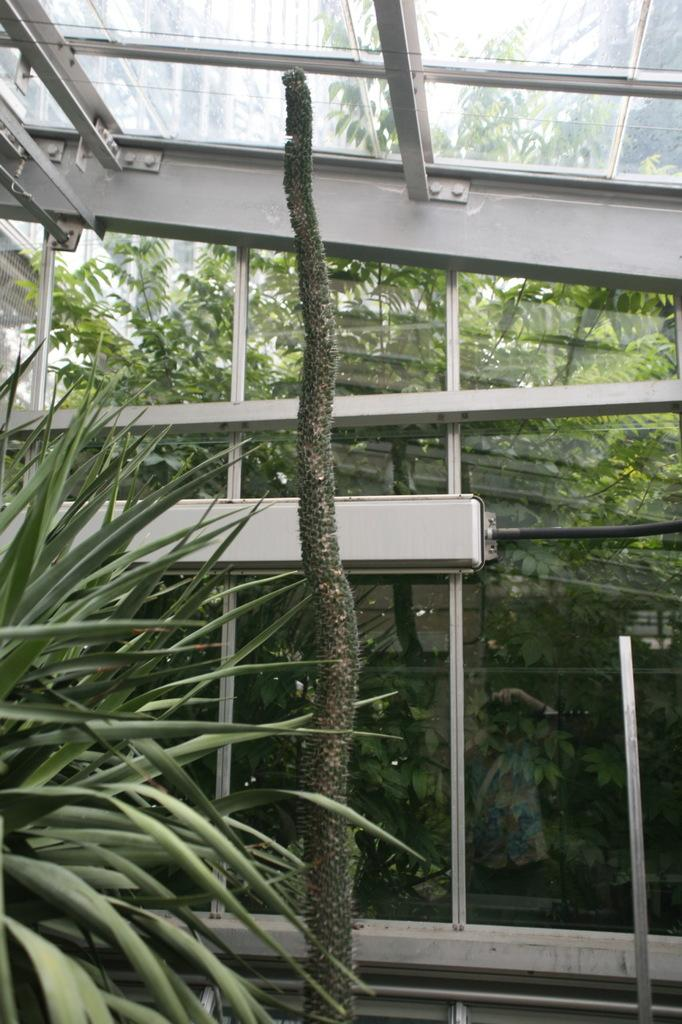What is located in the foreground of the image? There are plants in the foreground of the image. What structure can be seen in the background of the image? There is a glass shed in the background of the image. What type of vegetation is visible behind the glass shed? There are trees behind the glass shed in the background of the image. What is the price of the guide featured in the image? There is no guide present in the image, so it is not possible to determine its price. Can you tell me how many clams are visible in the image? There are no clams present in the image. 